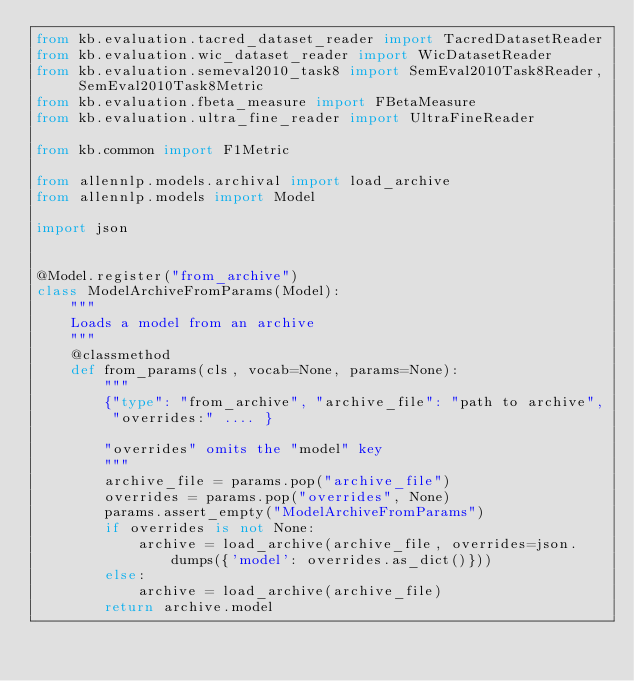<code> <loc_0><loc_0><loc_500><loc_500><_Python_>from kb.evaluation.tacred_dataset_reader import TacredDatasetReader
from kb.evaluation.wic_dataset_reader import WicDatasetReader
from kb.evaluation.semeval2010_task8 import SemEval2010Task8Reader, SemEval2010Task8Metric
from kb.evaluation.fbeta_measure import FBetaMeasure
from kb.evaluation.ultra_fine_reader import UltraFineReader

from kb.common import F1Metric

from allennlp.models.archival import load_archive
from allennlp.models import Model

import json


@Model.register("from_archive")
class ModelArchiveFromParams(Model):
    """
    Loads a model from an archive
    """
    @classmethod
    def from_params(cls, vocab=None, params=None):
        """
        {"type": "from_archive", "archive_file": "path to archive",
         "overrides:" .... }

        "overrides" omits the "model" key
        """
        archive_file = params.pop("archive_file")
        overrides = params.pop("overrides", None)
        params.assert_empty("ModelArchiveFromParams")
        if overrides is not None:
            archive = load_archive(archive_file, overrides=json.dumps({'model': overrides.as_dict()}))
        else:
            archive = load_archive(archive_file)
        return archive.model

</code> 